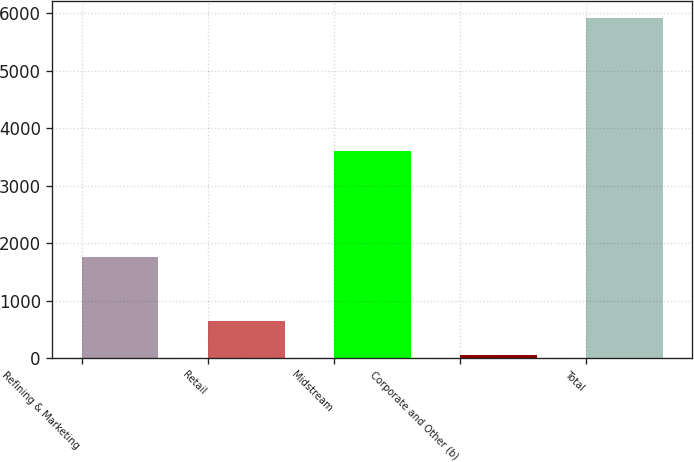Convert chart to OTSL. <chart><loc_0><loc_0><loc_500><loc_500><bar_chart><fcel>Refining & Marketing<fcel>Retail<fcel>Midstream<fcel>Corporate and Other (b)<fcel>Total<nl><fcel>1750<fcel>645<fcel>3600<fcel>60<fcel>5910<nl></chart> 